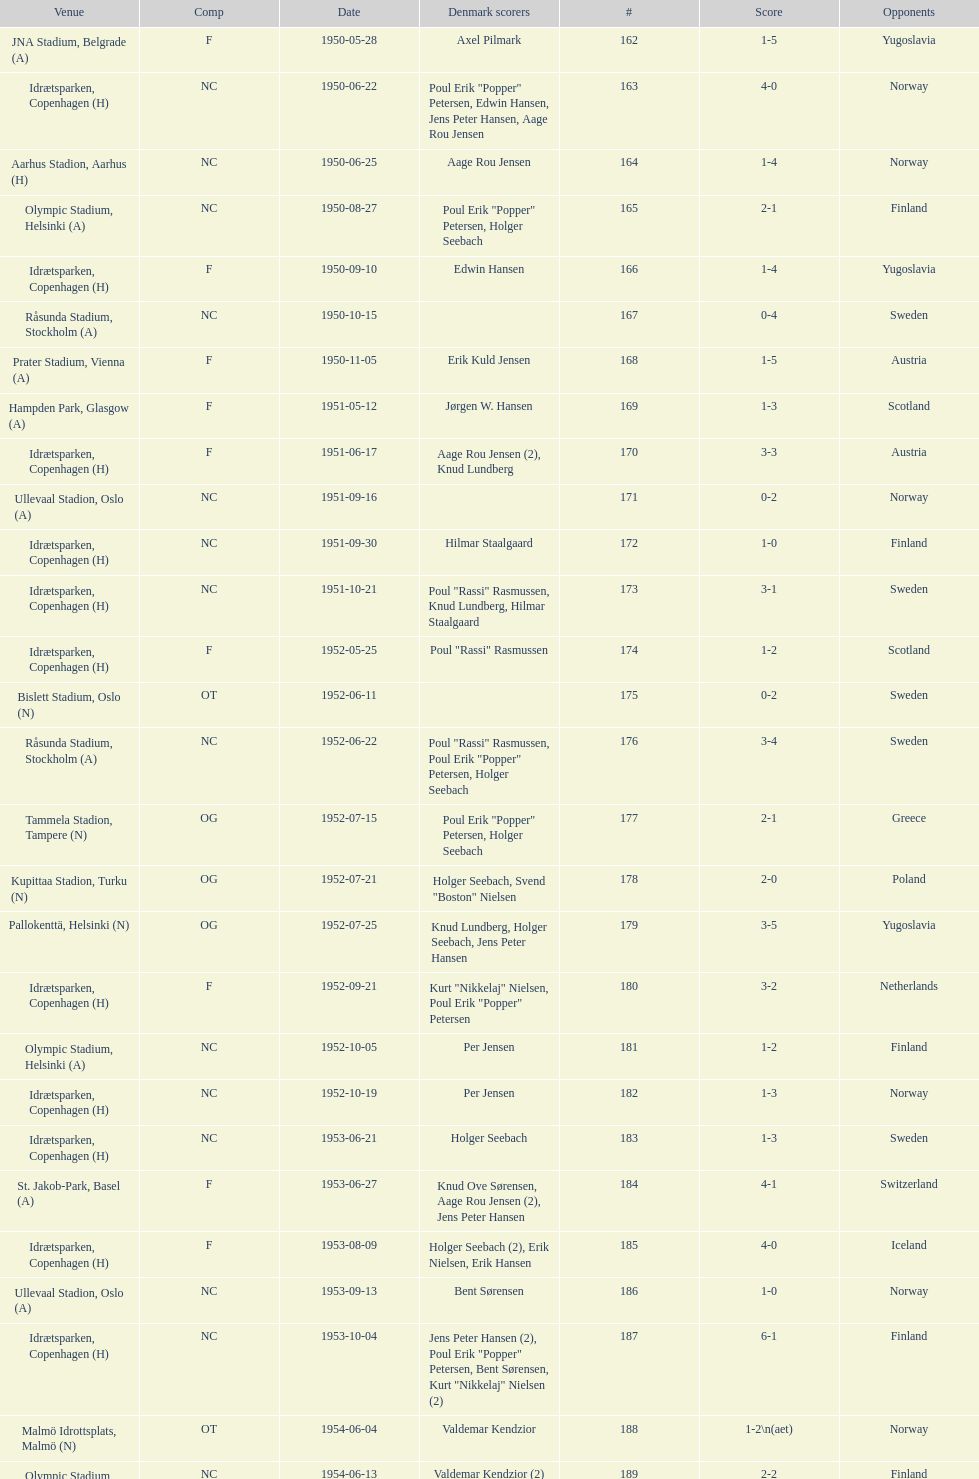Is denmark better against sweden or england? Sweden. 